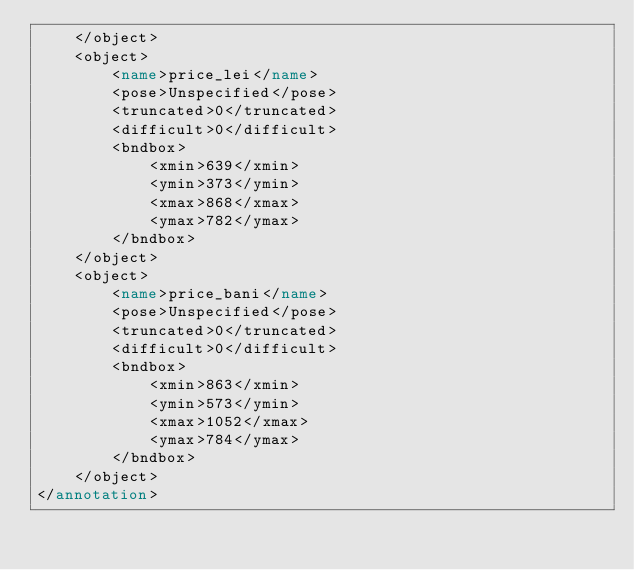Convert code to text. <code><loc_0><loc_0><loc_500><loc_500><_XML_>	</object>
	<object>
		<name>price_lei</name>
		<pose>Unspecified</pose>
		<truncated>0</truncated>
		<difficult>0</difficult>
		<bndbox>
			<xmin>639</xmin>
			<ymin>373</ymin>
			<xmax>868</xmax>
			<ymax>782</ymax>
		</bndbox>
	</object>
	<object>
		<name>price_bani</name>
		<pose>Unspecified</pose>
		<truncated>0</truncated>
		<difficult>0</difficult>
		<bndbox>
			<xmin>863</xmin>
			<ymin>573</ymin>
			<xmax>1052</xmax>
			<ymax>784</ymax>
		</bndbox>
	</object>
</annotation>
</code> 